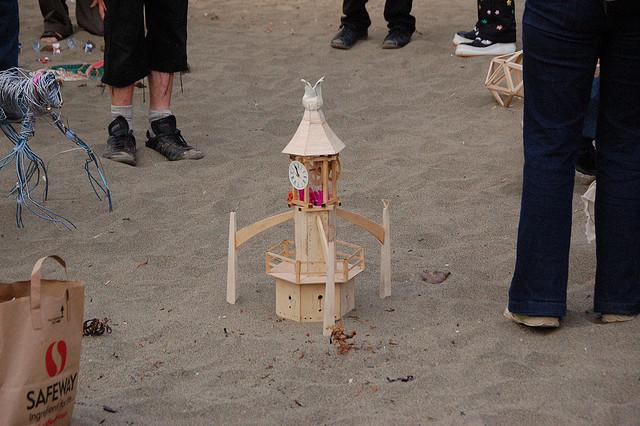Is this clock tower taller than the average adult male?
Keep it brief. No. What is on the ground?
Quick response, please. Sand. How many people are standing?
Write a very short answer. 5. Is this a miniature?
Concise answer only. Yes. 